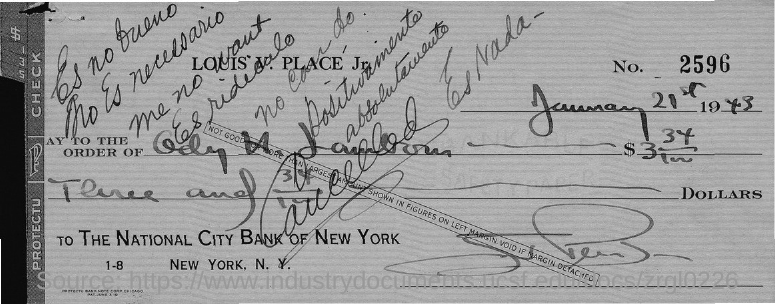What is the No. on the check?
Give a very brief answer. 2596. Which bank is mentioned?
Your response must be concise. The national city bank of new york. 